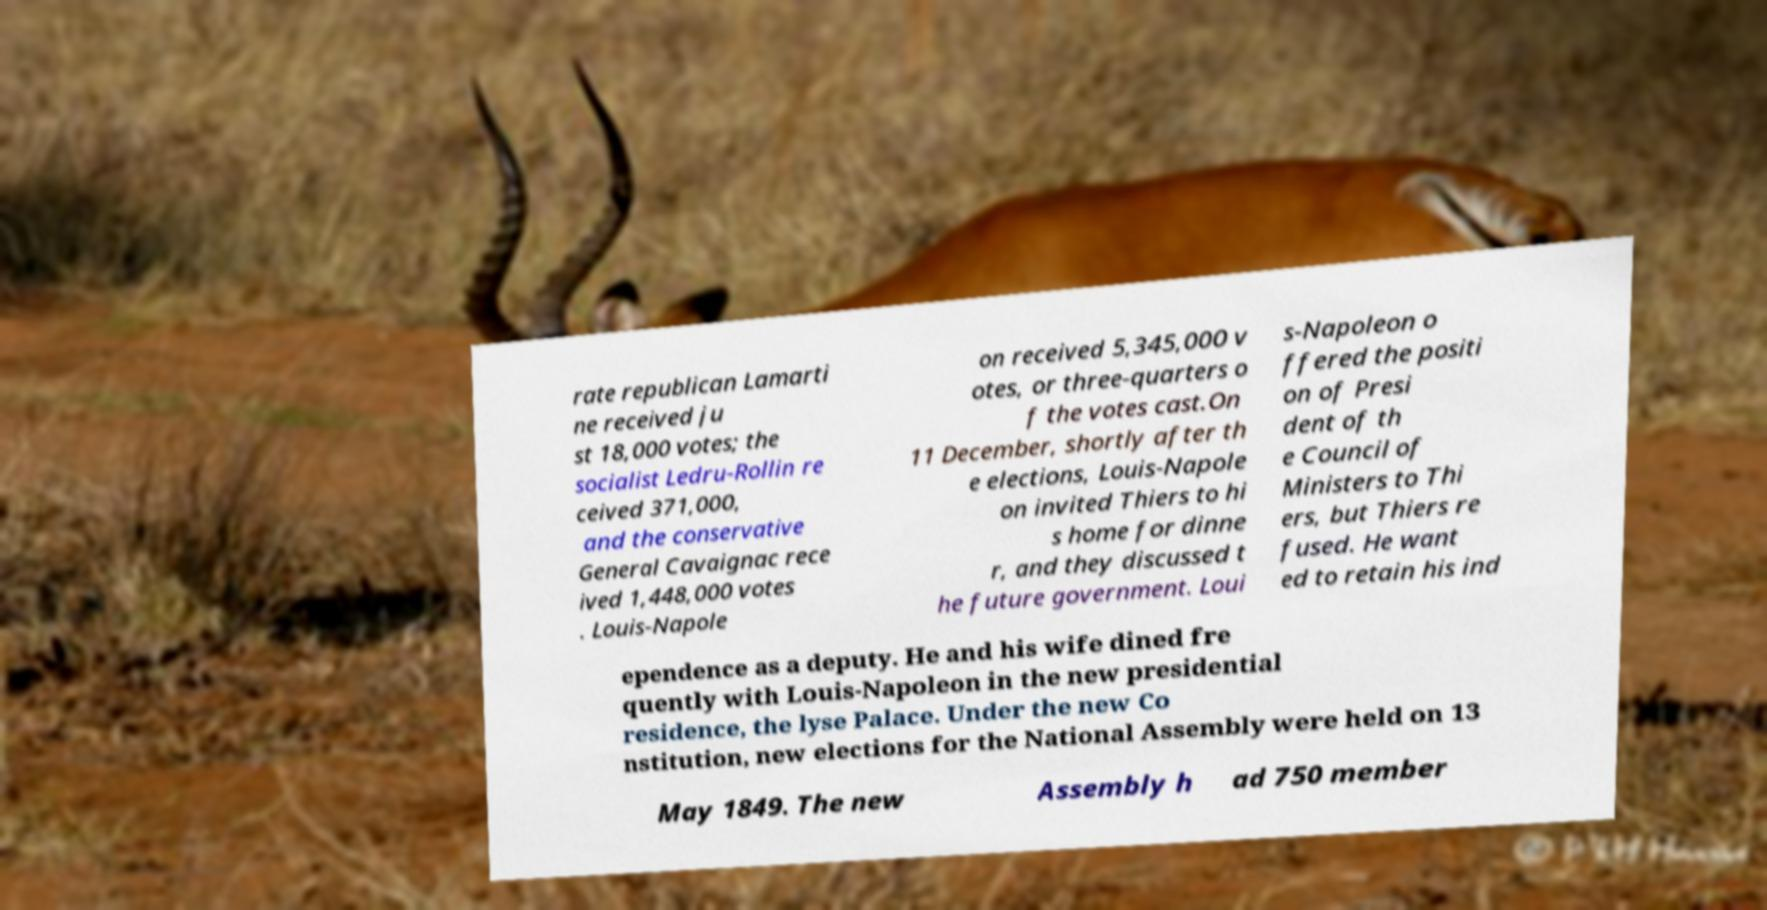Could you assist in decoding the text presented in this image and type it out clearly? rate republican Lamarti ne received ju st 18,000 votes; the socialist Ledru-Rollin re ceived 371,000, and the conservative General Cavaignac rece ived 1,448,000 votes . Louis-Napole on received 5,345,000 v otes, or three-quarters o f the votes cast.On 11 December, shortly after th e elections, Louis-Napole on invited Thiers to hi s home for dinne r, and they discussed t he future government. Loui s-Napoleon o ffered the positi on of Presi dent of th e Council of Ministers to Thi ers, but Thiers re fused. He want ed to retain his ind ependence as a deputy. He and his wife dined fre quently with Louis-Napoleon in the new presidential residence, the lyse Palace. Under the new Co nstitution, new elections for the National Assembly were held on 13 May 1849. The new Assembly h ad 750 member 